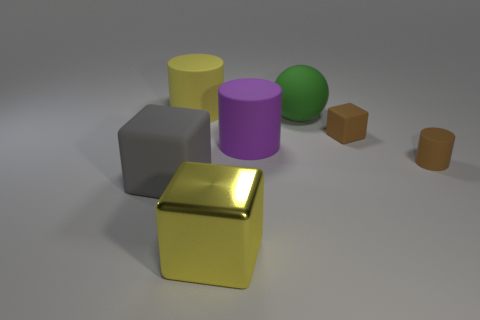Is the number of gray rubber objects less than the number of tiny brown objects?
Your response must be concise. Yes. How many tiny rubber cylinders are the same color as the small block?
Ensure brevity in your answer.  1. There is a cylinder that is the same color as the small rubber cube; what is its material?
Keep it short and to the point. Rubber. There is a big metal thing; does it have the same color as the big object that is behind the big green ball?
Your answer should be compact. Yes. Are there more metal things than cubes?
Offer a terse response. No. There is a brown matte thing that is the same shape as the purple object; what size is it?
Your response must be concise. Small. Is the gray object made of the same material as the cube that is behind the small rubber cylinder?
Provide a short and direct response. Yes. How many things are either big metal cubes or yellow cylinders?
Give a very brief answer. 2. Does the brown thing left of the tiny matte cylinder have the same size as the rubber cube to the left of the brown matte block?
Provide a succinct answer. No. How many cylinders are green things or large things?
Offer a terse response. 2. 